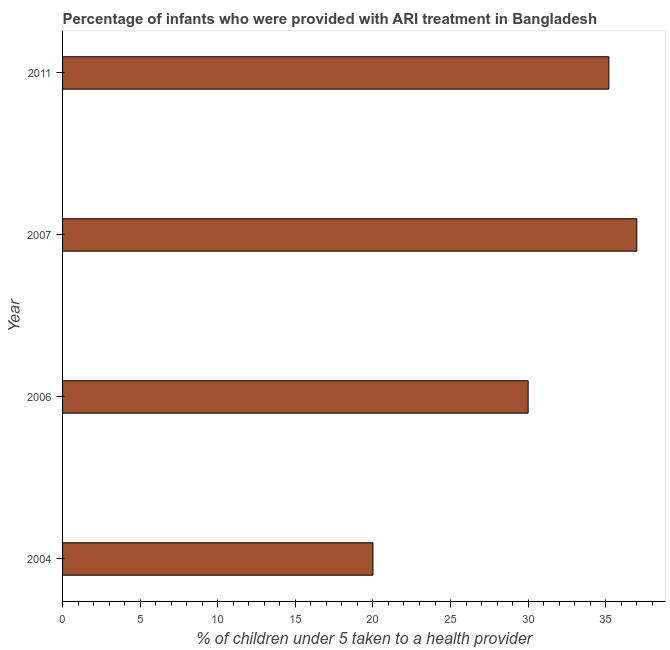Does the graph contain any zero values?
Your answer should be compact. No. Does the graph contain grids?
Make the answer very short. No. What is the title of the graph?
Keep it short and to the point. Percentage of infants who were provided with ARI treatment in Bangladesh. What is the label or title of the X-axis?
Make the answer very short. % of children under 5 taken to a health provider. What is the label or title of the Y-axis?
Give a very brief answer. Year. What is the percentage of children who were provided with ari treatment in 2007?
Ensure brevity in your answer.  37. Across all years, what is the minimum percentage of children who were provided with ari treatment?
Give a very brief answer. 20. In which year was the percentage of children who were provided with ari treatment minimum?
Offer a terse response. 2004. What is the sum of the percentage of children who were provided with ari treatment?
Make the answer very short. 122.2. What is the difference between the percentage of children who were provided with ari treatment in 2004 and 2006?
Offer a terse response. -10. What is the average percentage of children who were provided with ari treatment per year?
Offer a very short reply. 30.55. What is the median percentage of children who were provided with ari treatment?
Offer a very short reply. 32.6. In how many years, is the percentage of children who were provided with ari treatment greater than 3 %?
Ensure brevity in your answer.  4. Do a majority of the years between 2007 and 2004 (inclusive) have percentage of children who were provided with ari treatment greater than 1 %?
Offer a terse response. Yes. What is the ratio of the percentage of children who were provided with ari treatment in 2007 to that in 2011?
Your response must be concise. 1.05. Is the percentage of children who were provided with ari treatment in 2004 less than that in 2007?
Give a very brief answer. Yes. Is the difference between the percentage of children who were provided with ari treatment in 2007 and 2011 greater than the difference between any two years?
Your response must be concise. No. What is the difference between the highest and the second highest percentage of children who were provided with ari treatment?
Provide a short and direct response. 1.8. Is the sum of the percentage of children who were provided with ari treatment in 2004 and 2006 greater than the maximum percentage of children who were provided with ari treatment across all years?
Your answer should be compact. Yes. How many bars are there?
Keep it short and to the point. 4. Are the values on the major ticks of X-axis written in scientific E-notation?
Keep it short and to the point. No. What is the % of children under 5 taken to a health provider in 2004?
Offer a very short reply. 20. What is the % of children under 5 taken to a health provider of 2006?
Your answer should be compact. 30. What is the % of children under 5 taken to a health provider in 2011?
Give a very brief answer. 35.2. What is the difference between the % of children under 5 taken to a health provider in 2004 and 2006?
Provide a short and direct response. -10. What is the difference between the % of children under 5 taken to a health provider in 2004 and 2007?
Offer a very short reply. -17. What is the difference between the % of children under 5 taken to a health provider in 2004 and 2011?
Offer a terse response. -15.2. What is the difference between the % of children under 5 taken to a health provider in 2006 and 2007?
Your answer should be compact. -7. What is the ratio of the % of children under 5 taken to a health provider in 2004 to that in 2006?
Offer a very short reply. 0.67. What is the ratio of the % of children under 5 taken to a health provider in 2004 to that in 2007?
Ensure brevity in your answer.  0.54. What is the ratio of the % of children under 5 taken to a health provider in 2004 to that in 2011?
Your answer should be compact. 0.57. What is the ratio of the % of children under 5 taken to a health provider in 2006 to that in 2007?
Your response must be concise. 0.81. What is the ratio of the % of children under 5 taken to a health provider in 2006 to that in 2011?
Provide a succinct answer. 0.85. What is the ratio of the % of children under 5 taken to a health provider in 2007 to that in 2011?
Offer a very short reply. 1.05. 